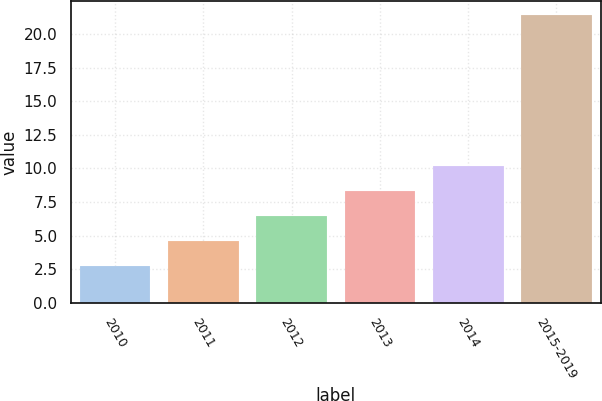<chart> <loc_0><loc_0><loc_500><loc_500><bar_chart><fcel>2010<fcel>2011<fcel>2012<fcel>2013<fcel>2014<fcel>2015-2019<nl><fcel>2.7<fcel>4.57<fcel>6.44<fcel>8.31<fcel>10.18<fcel>21.4<nl></chart> 